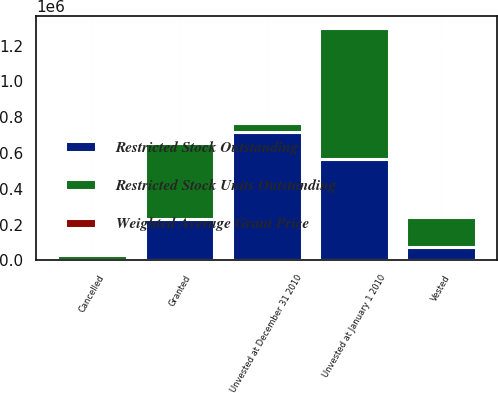Convert chart to OTSL. <chart><loc_0><loc_0><loc_500><loc_500><stacked_bar_chart><ecel><fcel>Unvested at January 1 2010<fcel>Granted<fcel>Vested<fcel>Cancelled<fcel>Unvested at December 31 2010<nl><fcel>Restricted Stock Outstanding<fcel>566449<fcel>231037<fcel>74144<fcel>3366<fcel>719976<nl><fcel>Weighted Average Grant Price<fcel>39.21<fcel>73.75<fcel>41.58<fcel>52.07<fcel>49.99<nl><fcel>Restricted Stock Units Outstanding<fcel>733687<fcel>423002<fcel>165799<fcel>25818<fcel>49981<nl></chart> 